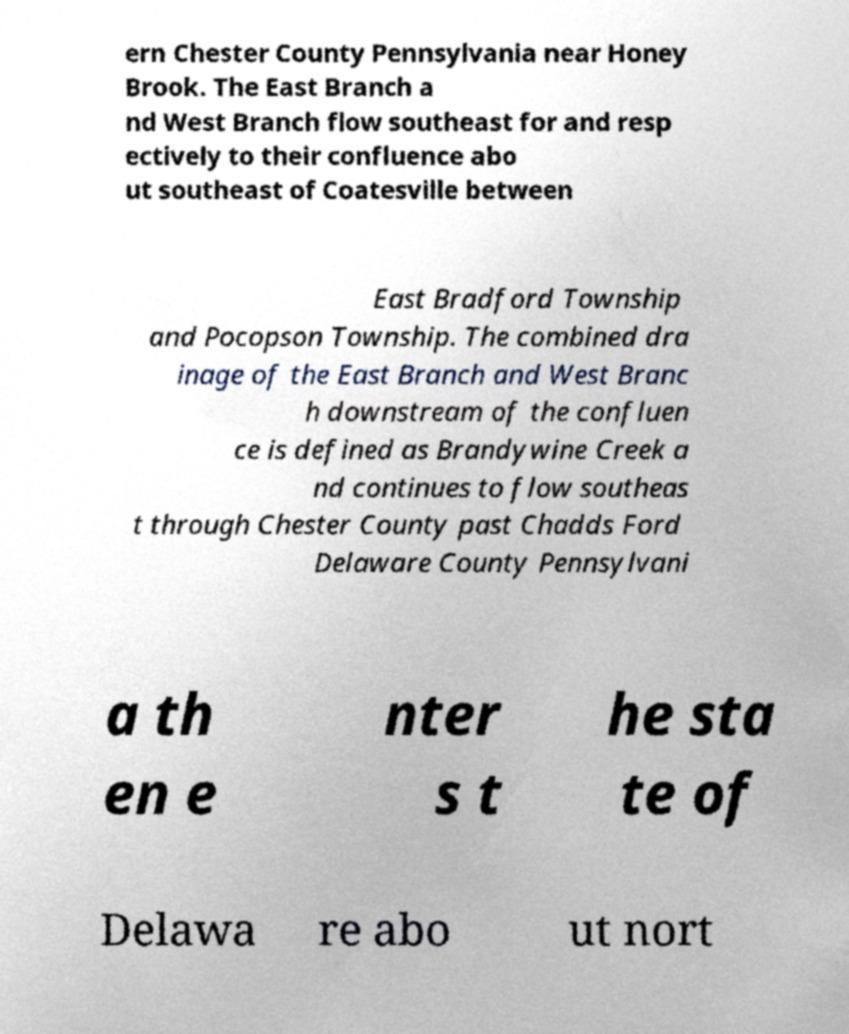Please read and relay the text visible in this image. What does it say? ern Chester County Pennsylvania near Honey Brook. The East Branch a nd West Branch flow southeast for and resp ectively to their confluence abo ut southeast of Coatesville between East Bradford Township and Pocopson Township. The combined dra inage of the East Branch and West Branc h downstream of the confluen ce is defined as Brandywine Creek a nd continues to flow southeas t through Chester County past Chadds Ford Delaware County Pennsylvani a th en e nter s t he sta te of Delawa re abo ut nort 